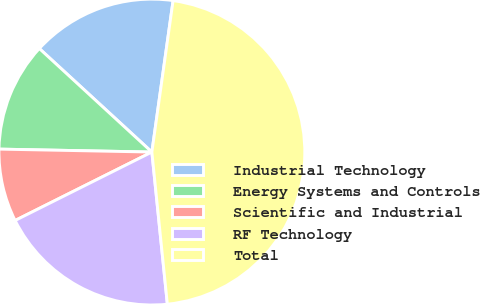<chart> <loc_0><loc_0><loc_500><loc_500><pie_chart><fcel>Industrial Technology<fcel>Energy Systems and Controls<fcel>Scientific and Industrial<fcel>RF Technology<fcel>Total<nl><fcel>15.38%<fcel>11.53%<fcel>7.69%<fcel>19.23%<fcel>46.17%<nl></chart> 